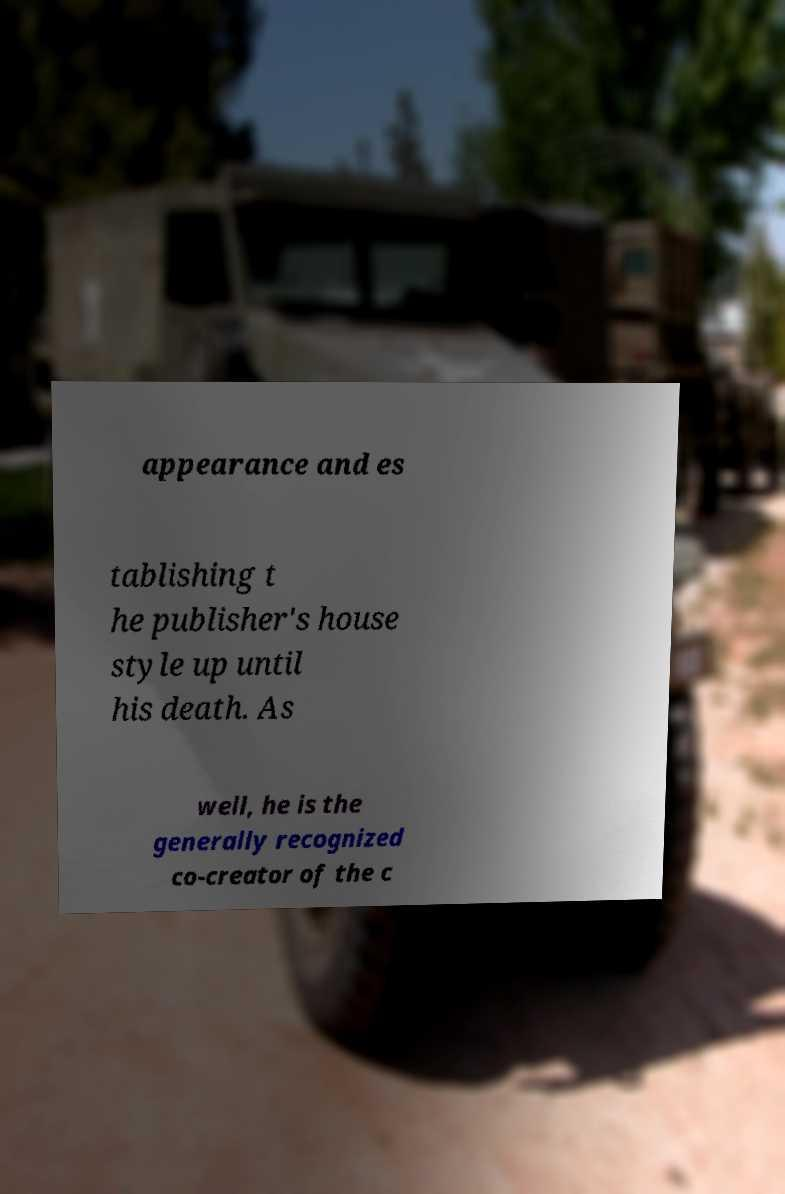Please identify and transcribe the text found in this image. appearance and es tablishing t he publisher's house style up until his death. As well, he is the generally recognized co-creator of the c 